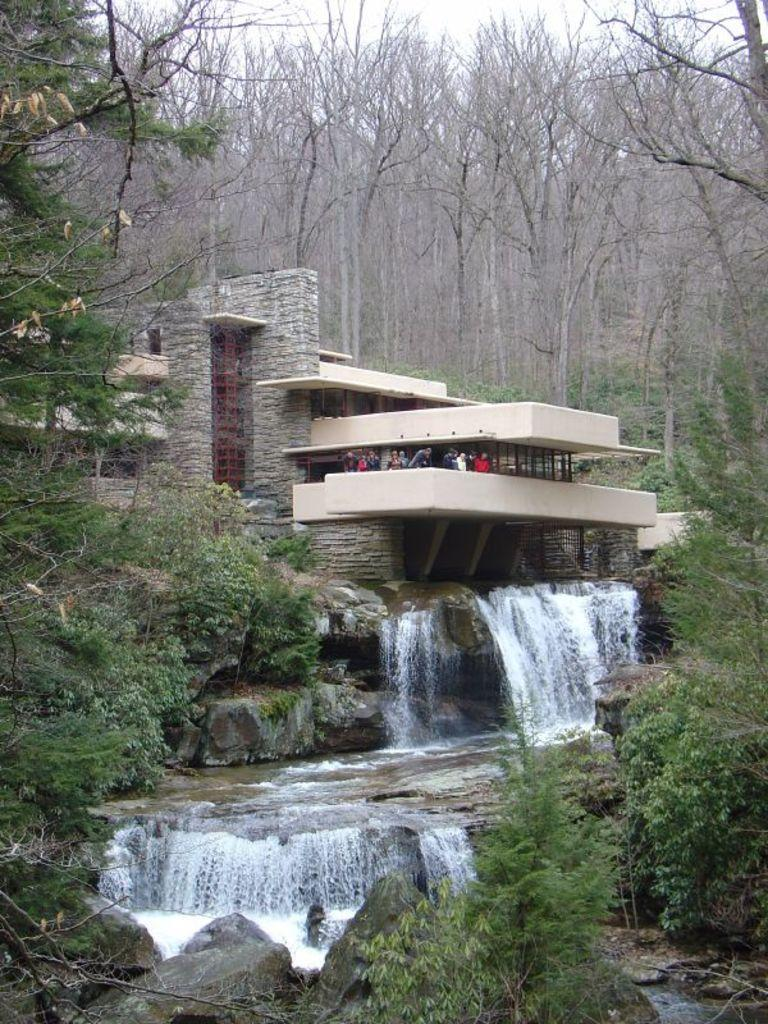What type of structure is present in the image? There is a building in the image. What can be seen inside the building? There is a group of people standing inside the building. What natural element is visible in the image? There is water-flow visible in the image. What type of geological feature is present in the image? There are rocks in the image. What type of vegetation is present in the image? There is a group of trees in the image. How would you describe the weather based on the image? The sky is visible in the image and appears cloudy. Where is the cat located in the image? There is no cat present in the image. What type of error can be seen in the image? There is no error present in the image. 